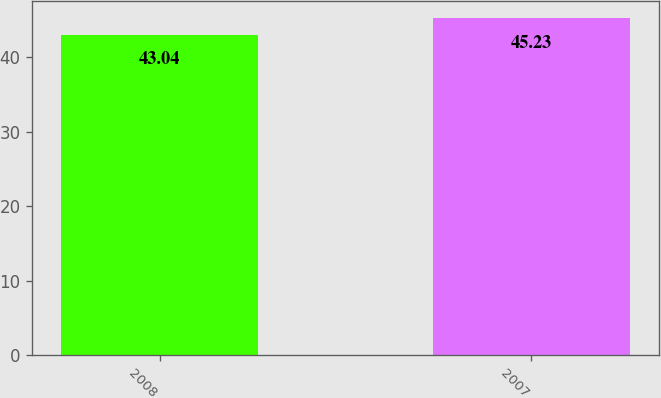Convert chart to OTSL. <chart><loc_0><loc_0><loc_500><loc_500><bar_chart><fcel>2008<fcel>2007<nl><fcel>43.04<fcel>45.23<nl></chart> 